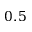<formula> <loc_0><loc_0><loc_500><loc_500>0 . 5</formula> 